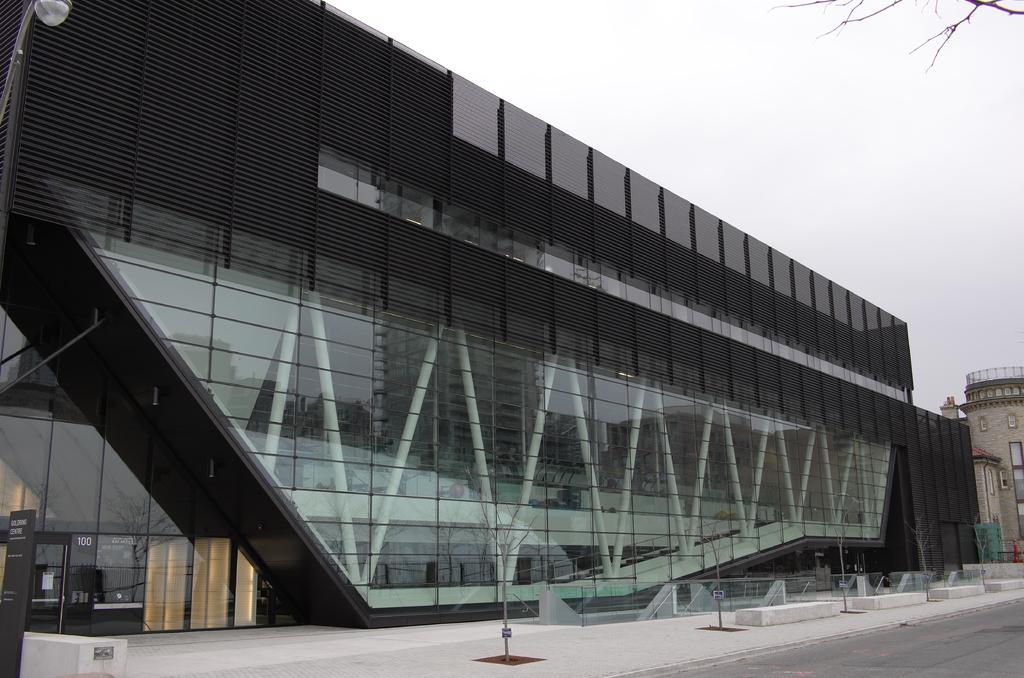What is the main feature of the image? There is a road in the image. What can be seen in the distance behind the road? There are buildings in the background of the image. Can you describe the lighting in the image? There is light visible in the image. What is visible at the top of the image? The sky is visible at the top of the image. Where is the table located in the image? There is no table present in the image. What type of screw can be seen holding the buildings together in the image? There are no screws visible in the image, and the buildings are not being held together by screws. 